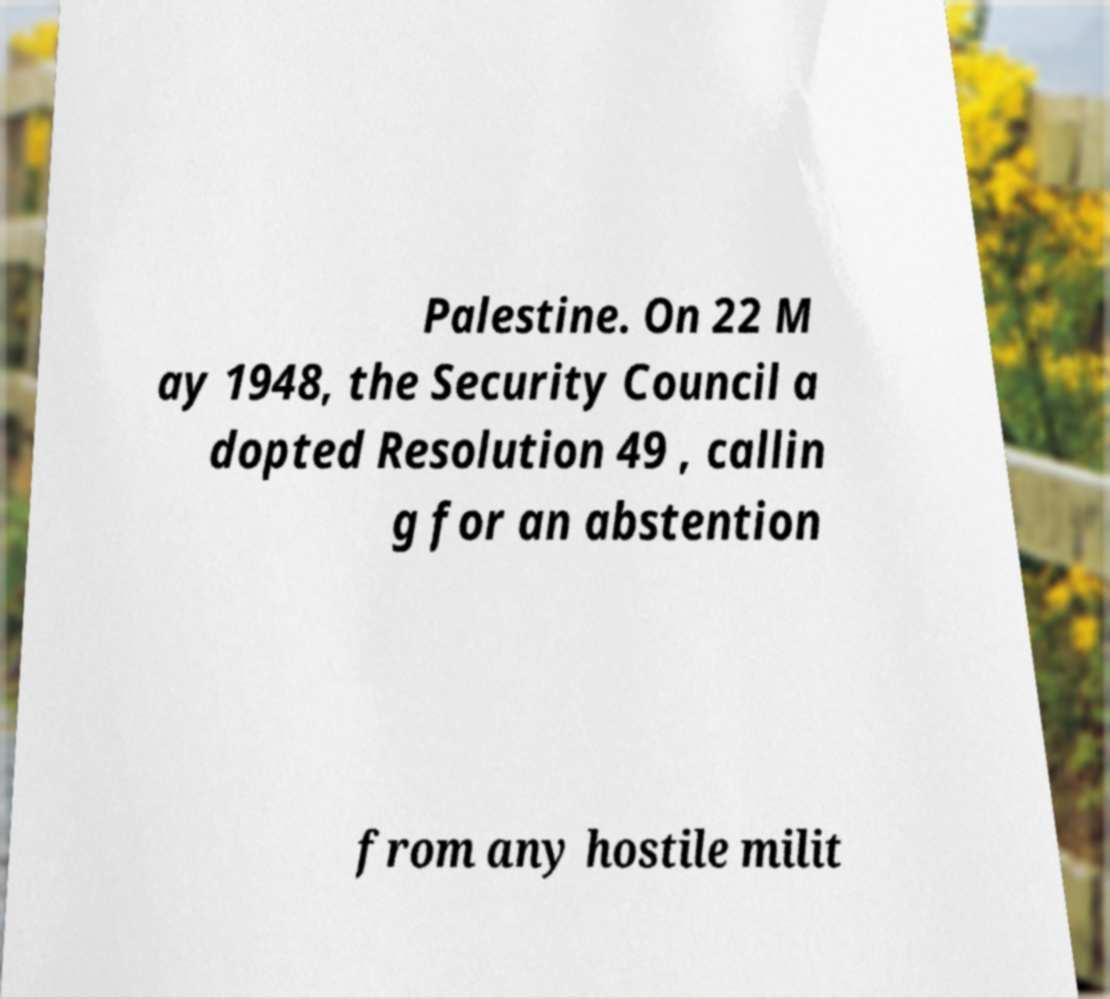Could you extract and type out the text from this image? Palestine. On 22 M ay 1948, the Security Council a dopted Resolution 49 , callin g for an abstention from any hostile milit 